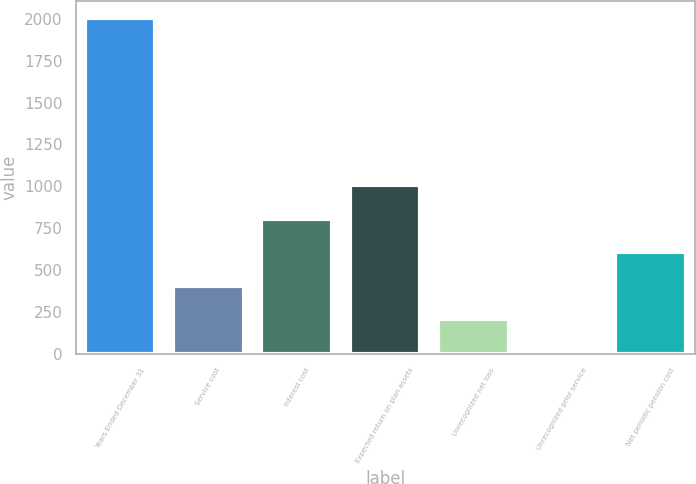Convert chart to OTSL. <chart><loc_0><loc_0><loc_500><loc_500><bar_chart><fcel>Years Ended December 31<fcel>Service cost<fcel>Interest cost<fcel>Expected return on plan assets<fcel>Unrecognized net loss<fcel>Unrecognized prior service<fcel>Net periodic pension cost<nl><fcel>2005<fcel>405<fcel>805<fcel>1005<fcel>205<fcel>5<fcel>605<nl></chart> 